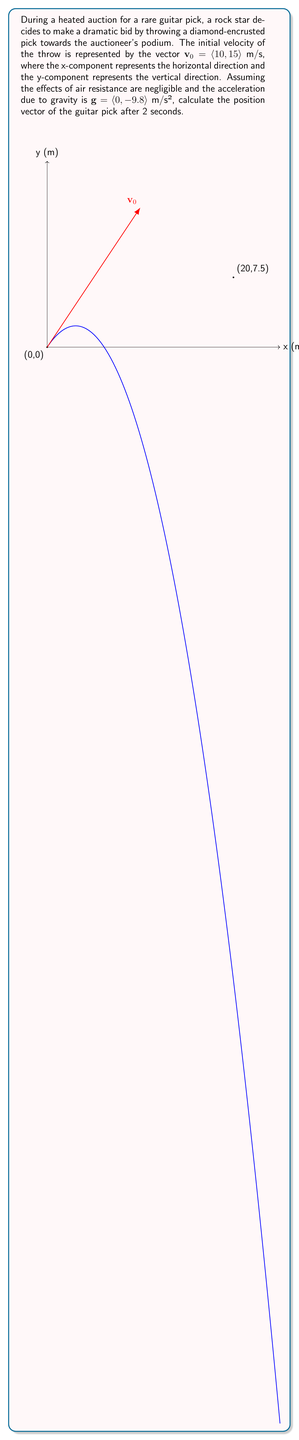Show me your answer to this math problem. Let's solve this step-by-step using vector addition:

1) The position vector $\mathbf{r}(t)$ at time $t$ is given by:

   $\mathbf{r}(t) = \mathbf{r}_0 + \mathbf{v}_0t + \frac{1}{2}\mathbf{g}t^2$

   where $\mathbf{r}_0$ is the initial position vector.

2) Given:
   - Initial position: $\mathbf{r}_0 = \langle 0, 0 \rangle$ (assuming the throw starts at the origin)
   - Initial velocity: $\mathbf{v}_0 = \langle 10, 15 \rangle$ m/s
   - Acceleration due to gravity: $\mathbf{g} = \langle 0, -9.8 \rangle$ m/s²
   - Time: $t = 2$ s

3) Let's substitute these values into our equation:

   $\mathbf{r}(2) = \langle 0, 0 \rangle + \langle 10, 15 \rangle \cdot 2 + \frac{1}{2}\langle 0, -9.8 \rangle \cdot 2^2$

4) Simplify:
   $\mathbf{r}(2) = \langle 0, 0 \rangle + \langle 20, 30 \rangle + \langle 0, -19.6 \rangle$

5) Add the vectors:
   $\mathbf{r}(2) = \langle 0+20+0, 0+30-19.6 \rangle$

6) Simplify:
   $\mathbf{r}(2) = \langle 20, 10.4 \rangle$

Therefore, after 2 seconds, the position vector of the guitar pick is $\langle 20, 10.4 \rangle$ meters.
Answer: $\langle 20, 10.4 \rangle$ m 